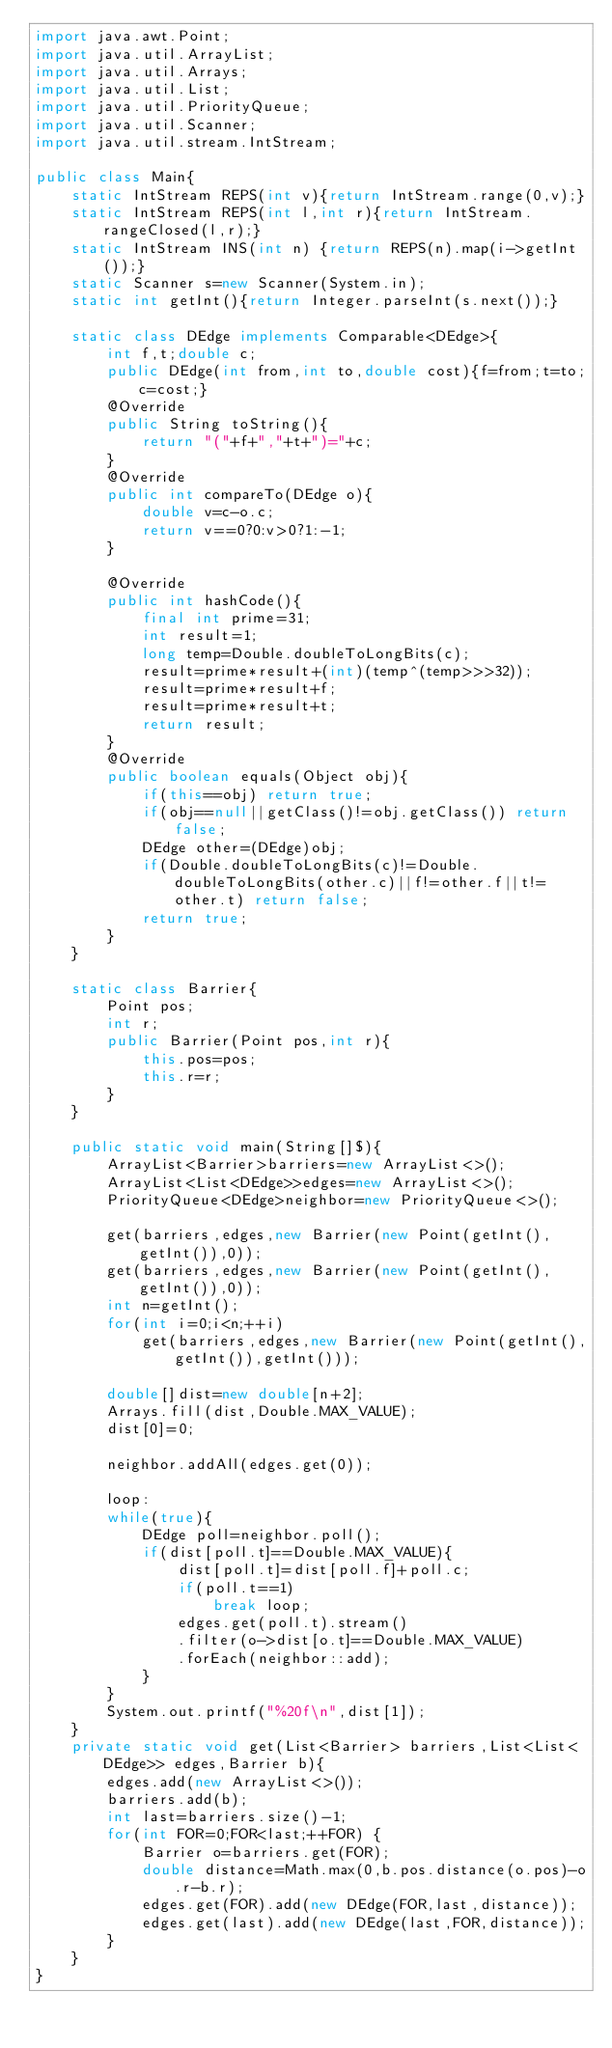<code> <loc_0><loc_0><loc_500><loc_500><_Java_>import java.awt.Point;
import java.util.ArrayList;
import java.util.Arrays;
import java.util.List;
import java.util.PriorityQueue;
import java.util.Scanner;
import java.util.stream.IntStream;

public class Main{
	static IntStream REPS(int v){return IntStream.range(0,v);}
	static IntStream REPS(int l,int r){return IntStream.rangeClosed(l,r);}
	static IntStream INS(int n) {return REPS(n).map(i->getInt());}
	static Scanner s=new Scanner(System.in);
	static int getInt(){return Integer.parseInt(s.next());}

	static class DEdge implements Comparable<DEdge>{
		int f,t;double c;
		public DEdge(int from,int to,double cost){f=from;t=to;c=cost;}
		@Override
		public String toString(){
			return "("+f+","+t+")="+c;
		}
		@Override
		public int compareTo(DEdge o){
			double v=c-o.c;
			return v==0?0:v>0?1:-1;
		}

		@Override
		public int hashCode(){
			final int prime=31;
			int result=1;
			long temp=Double.doubleToLongBits(c);
			result=prime*result+(int)(temp^(temp>>>32));
			result=prime*result+f;
			result=prime*result+t;
			return result;
		}
		@Override
		public boolean equals(Object obj){
			if(this==obj) return true;
			if(obj==null||getClass()!=obj.getClass()) return false;
			DEdge other=(DEdge)obj;
			if(Double.doubleToLongBits(c)!=Double.doubleToLongBits(other.c)||f!=other.f||t!=other.t) return false;
			return true;
		}
	}

	static class Barrier{
		Point pos;
		int r;
		public Barrier(Point pos,int r){
			this.pos=pos;
			this.r=r;
		}
	}

	public static void main(String[]$){
		ArrayList<Barrier>barriers=new ArrayList<>();
		ArrayList<List<DEdge>>edges=new ArrayList<>();
		PriorityQueue<DEdge>neighbor=new PriorityQueue<>();

		get(barriers,edges,new Barrier(new Point(getInt(),getInt()),0));
		get(barriers,edges,new Barrier(new Point(getInt(),getInt()),0));
		int n=getInt();
		for(int i=0;i<n;++i)
			get(barriers,edges,new Barrier(new Point(getInt(),getInt()),getInt()));

		double[]dist=new double[n+2];
		Arrays.fill(dist,Double.MAX_VALUE);
		dist[0]=0;

		neighbor.addAll(edges.get(0));

		loop:
		while(true){
			DEdge poll=neighbor.poll();
			if(dist[poll.t]==Double.MAX_VALUE){
				dist[poll.t]=dist[poll.f]+poll.c;
				if(poll.t==1)
					break loop;
				edges.get(poll.t).stream()
				.filter(o->dist[o.t]==Double.MAX_VALUE)
				.forEach(neighbor::add);
			}
		}
		System.out.printf("%20f\n",dist[1]);
	}
	private static void get(List<Barrier> barriers,List<List<DEdge>> edges,Barrier b){
		edges.add(new ArrayList<>());
		barriers.add(b);
		int last=barriers.size()-1;
		for(int FOR=0;FOR<last;++FOR) {
			Barrier o=barriers.get(FOR);
			double distance=Math.max(0,b.pos.distance(o.pos)-o.r-b.r);
			edges.get(FOR).add(new DEdge(FOR,last,distance));
			edges.get(last).add(new DEdge(last,FOR,distance));
		}
	}
}</code> 